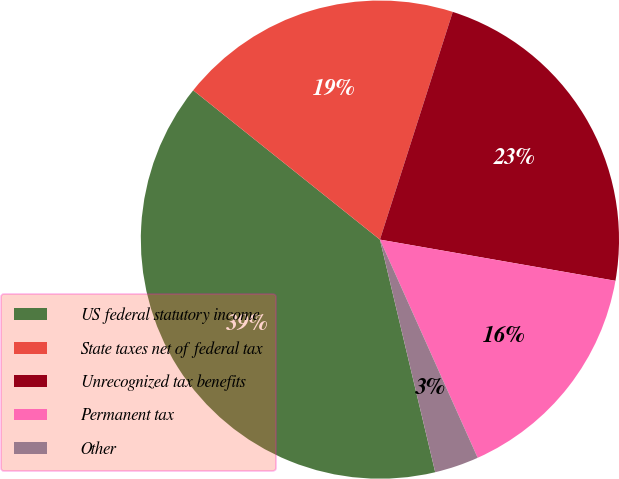<chart> <loc_0><loc_0><loc_500><loc_500><pie_chart><fcel>US federal statutory income<fcel>State taxes net of federal tax<fcel>Unrecognized tax benefits<fcel>Permanent tax<fcel>Other<nl><fcel>39.45%<fcel>19.19%<fcel>22.83%<fcel>15.54%<fcel>2.99%<nl></chart> 